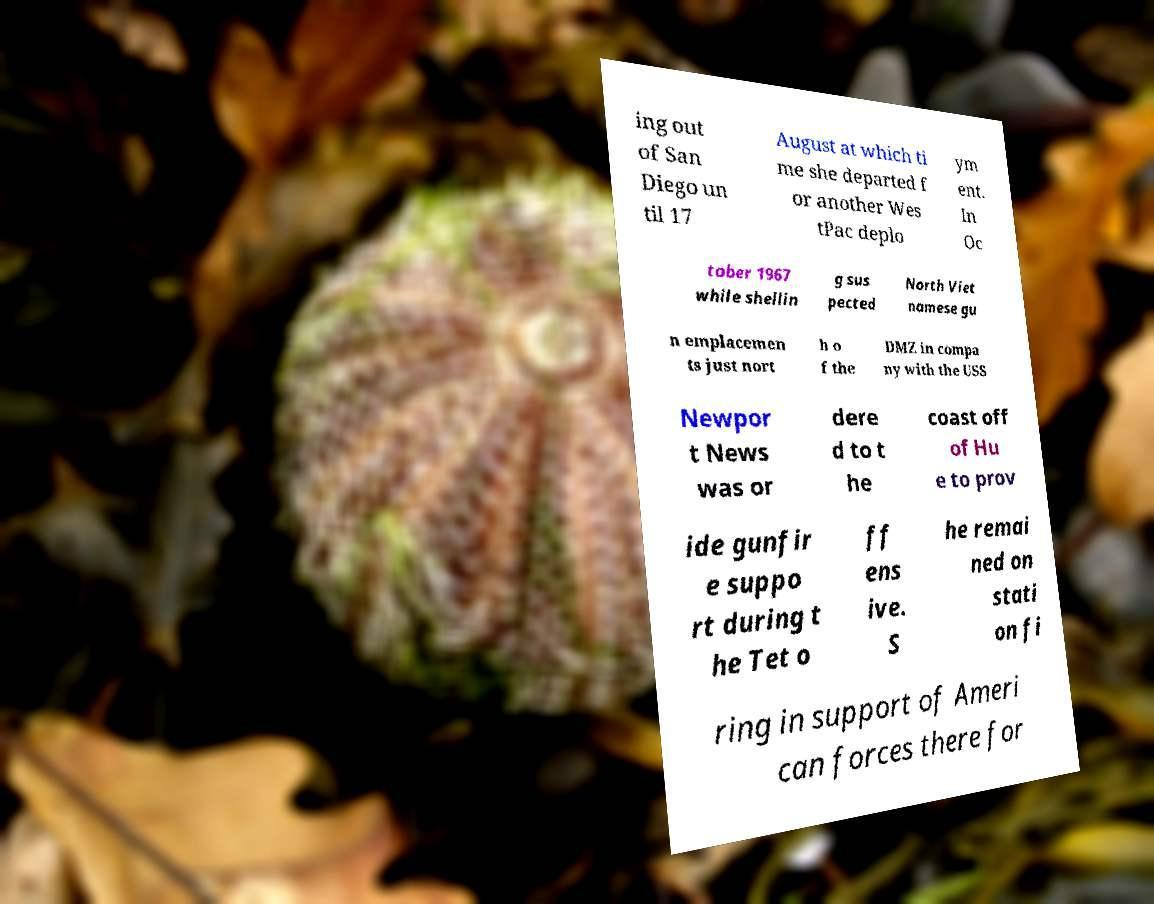I need the written content from this picture converted into text. Can you do that? ing out of San Diego un til 17 August at which ti me she departed f or another Wes tPac deplo ym ent. In Oc tober 1967 while shellin g sus pected North Viet namese gu n emplacemen ts just nort h o f the DMZ in compa ny with the USS Newpor t News was or dere d to t he coast off of Hu e to prov ide gunfir e suppo rt during t he Tet o ff ens ive. S he remai ned on stati on fi ring in support of Ameri can forces there for 